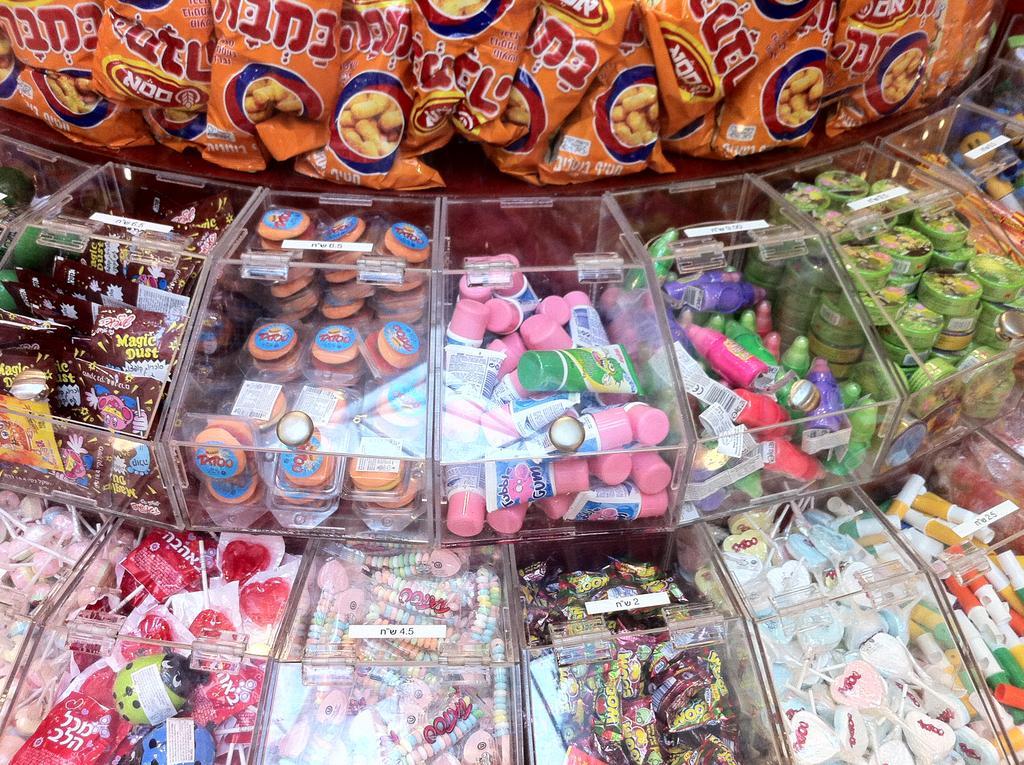Please provide a concise description of this image. In this picture we can see confectionery are present in boxes. At the top of the image there is a chips. 